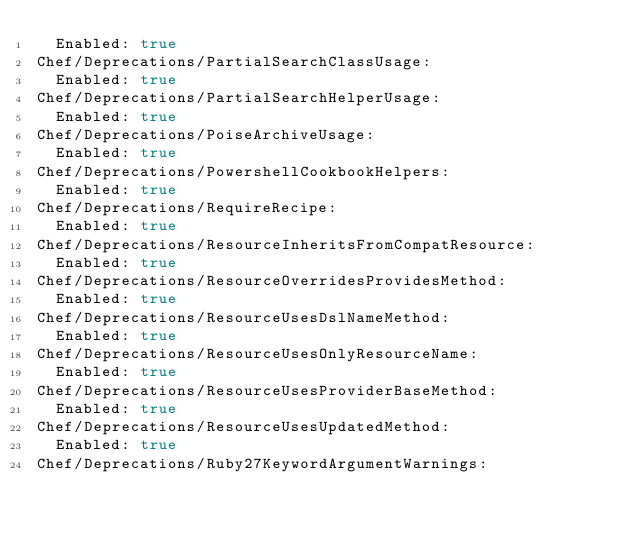Convert code to text. <code><loc_0><loc_0><loc_500><loc_500><_YAML_>  Enabled: true
Chef/Deprecations/PartialSearchClassUsage:
  Enabled: true
Chef/Deprecations/PartialSearchHelperUsage:
  Enabled: true
Chef/Deprecations/PoiseArchiveUsage:
  Enabled: true
Chef/Deprecations/PowershellCookbookHelpers:
  Enabled: true
Chef/Deprecations/RequireRecipe:
  Enabled: true
Chef/Deprecations/ResourceInheritsFromCompatResource:
  Enabled: true
Chef/Deprecations/ResourceOverridesProvidesMethod:
  Enabled: true
Chef/Deprecations/ResourceUsesDslNameMethod:
  Enabled: true
Chef/Deprecations/ResourceUsesOnlyResourceName:
  Enabled: true
Chef/Deprecations/ResourceUsesProviderBaseMethod:
  Enabled: true
Chef/Deprecations/ResourceUsesUpdatedMethod:
  Enabled: true
Chef/Deprecations/Ruby27KeywordArgumentWarnings:</code> 